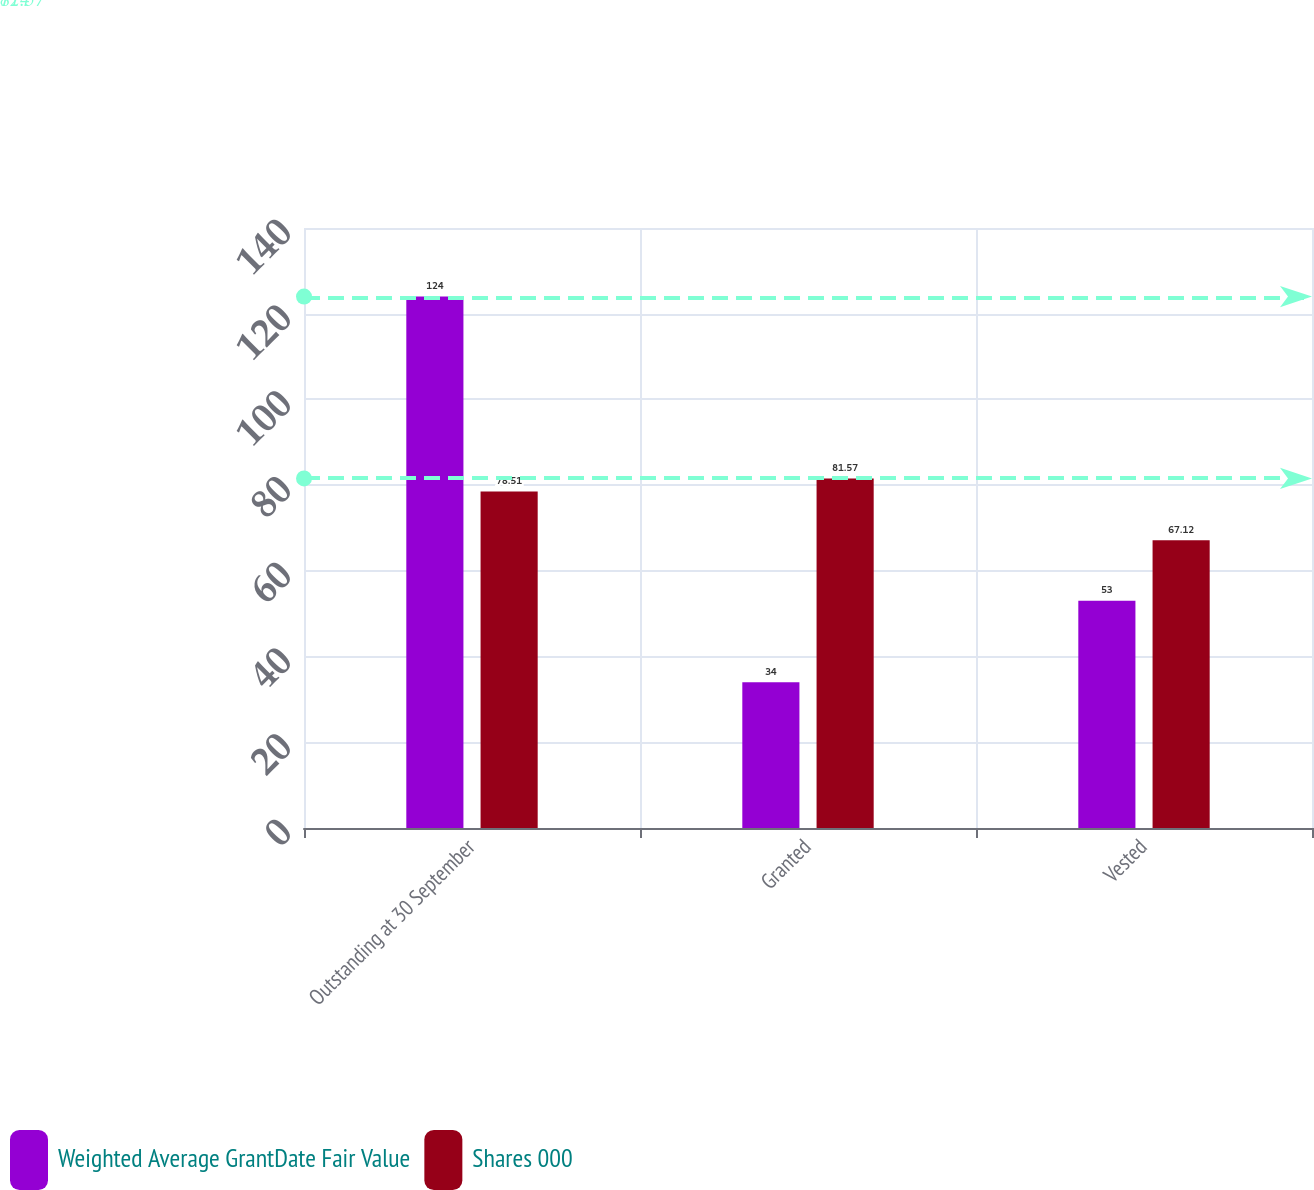Convert chart. <chart><loc_0><loc_0><loc_500><loc_500><stacked_bar_chart><ecel><fcel>Outstanding at 30 September<fcel>Granted<fcel>Vested<nl><fcel>Weighted Average GrantDate Fair Value<fcel>124<fcel>34<fcel>53<nl><fcel>Shares 000<fcel>78.51<fcel>81.57<fcel>67.12<nl></chart> 